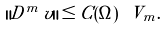Convert formula to latex. <formula><loc_0><loc_0><loc_500><loc_500>\| D ^ { m } \, v \| \leq C ( \Omega ) \ V _ { m } .</formula> 